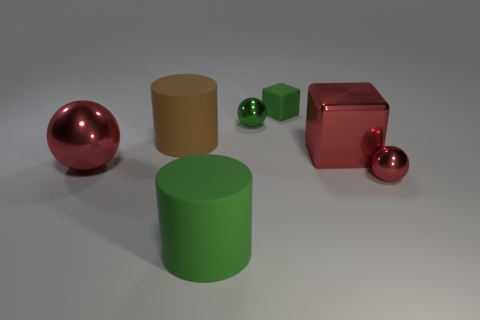What material is the tiny green sphere?
Your answer should be compact. Metal. There is a green ball right of the large red metal ball; what is its size?
Your answer should be very brief. Small. There is a tiny sphere that is left of the red cube; how many large red metal objects are behind it?
Ensure brevity in your answer.  0. There is a tiny object that is in front of the small green shiny sphere; is its shape the same as the small metallic thing behind the tiny red shiny object?
Give a very brief answer. Yes. How many things are both to the left of the tiny cube and behind the big brown cylinder?
Give a very brief answer. 1. Is there a big cylinder of the same color as the small matte block?
Make the answer very short. Yes. There is another green object that is the same size as the green metallic object; what shape is it?
Your answer should be compact. Cube. There is a tiny green metal object; are there any green things on the right side of it?
Offer a terse response. Yes. Is the big thing that is in front of the small red metallic sphere made of the same material as the small ball on the left side of the green cube?
Your answer should be compact. No. What number of cyan cubes have the same size as the green matte cylinder?
Make the answer very short. 0. 